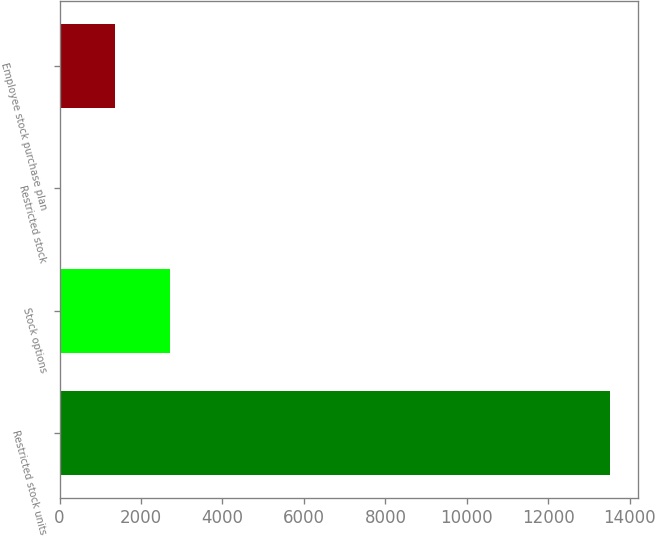Convert chart to OTSL. <chart><loc_0><loc_0><loc_500><loc_500><bar_chart><fcel>Restricted stock units<fcel>Stock options<fcel>Restricted stock<fcel>Employee stock purchase plan<nl><fcel>13524<fcel>2716.8<fcel>15<fcel>1365.9<nl></chart> 